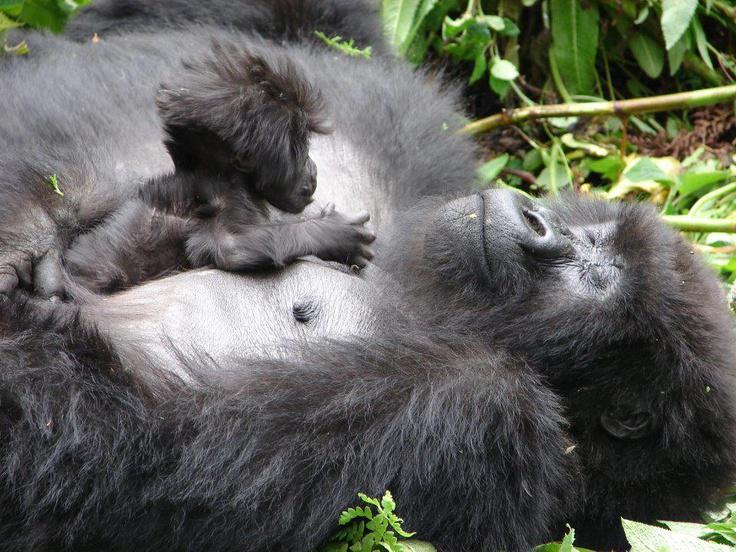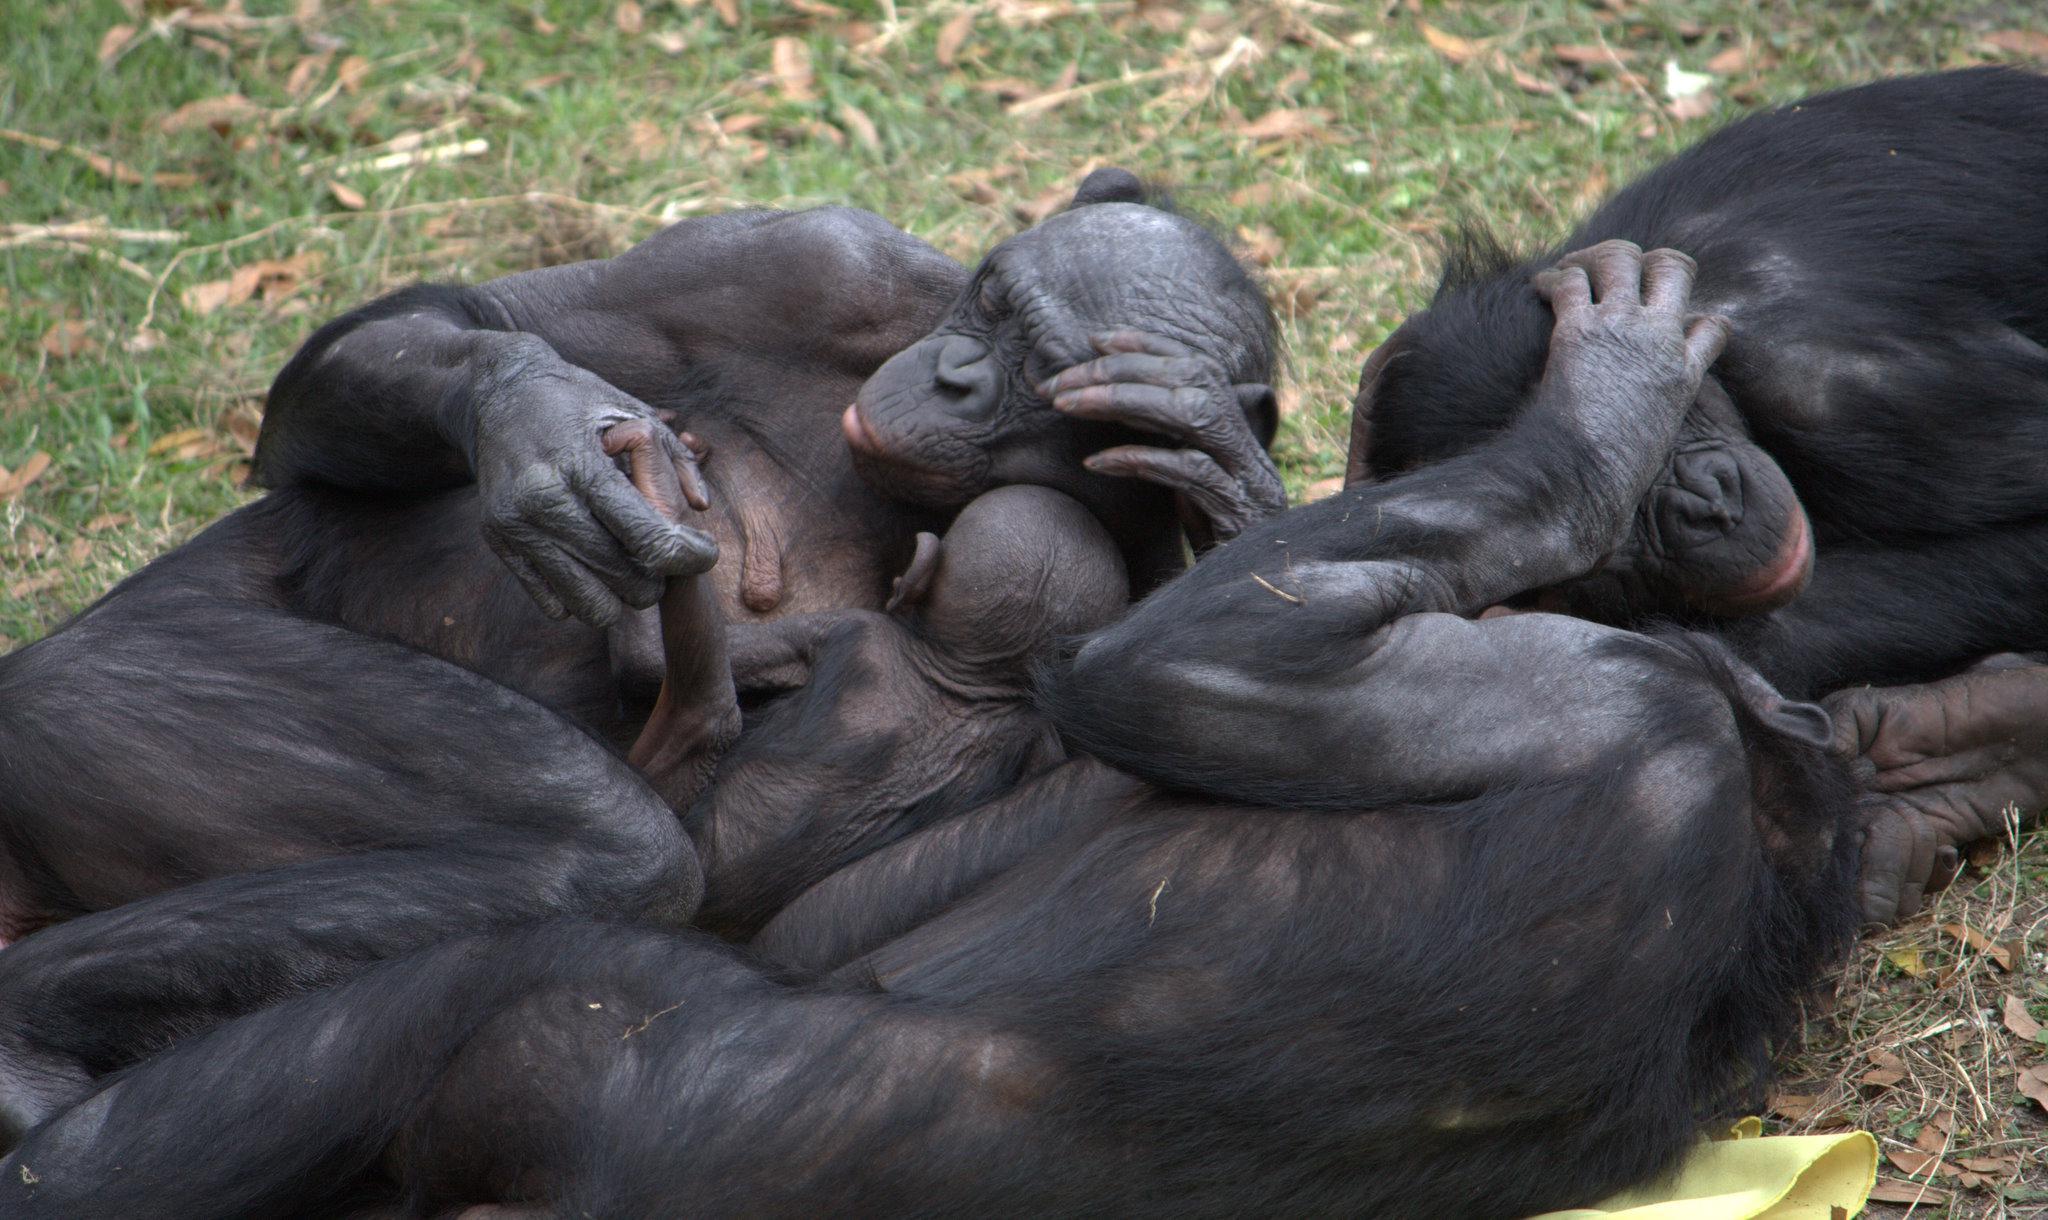The first image is the image on the left, the second image is the image on the right. For the images shown, is this caption "one chimp has its mouth open wide" true? Answer yes or no. No. The first image is the image on the left, the second image is the image on the right. Examine the images to the left and right. Is the description "There is at most 1 black monkey with its mouth open." accurate? Answer yes or no. No. 